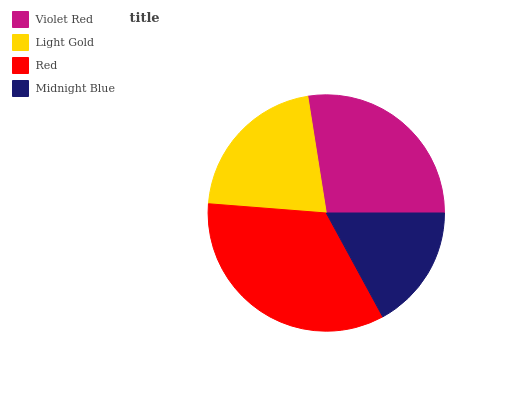Is Midnight Blue the minimum?
Answer yes or no. Yes. Is Red the maximum?
Answer yes or no. Yes. Is Light Gold the minimum?
Answer yes or no. No. Is Light Gold the maximum?
Answer yes or no. No. Is Violet Red greater than Light Gold?
Answer yes or no. Yes. Is Light Gold less than Violet Red?
Answer yes or no. Yes. Is Light Gold greater than Violet Red?
Answer yes or no. No. Is Violet Red less than Light Gold?
Answer yes or no. No. Is Violet Red the high median?
Answer yes or no. Yes. Is Light Gold the low median?
Answer yes or no. Yes. Is Midnight Blue the high median?
Answer yes or no. No. Is Violet Red the low median?
Answer yes or no. No. 